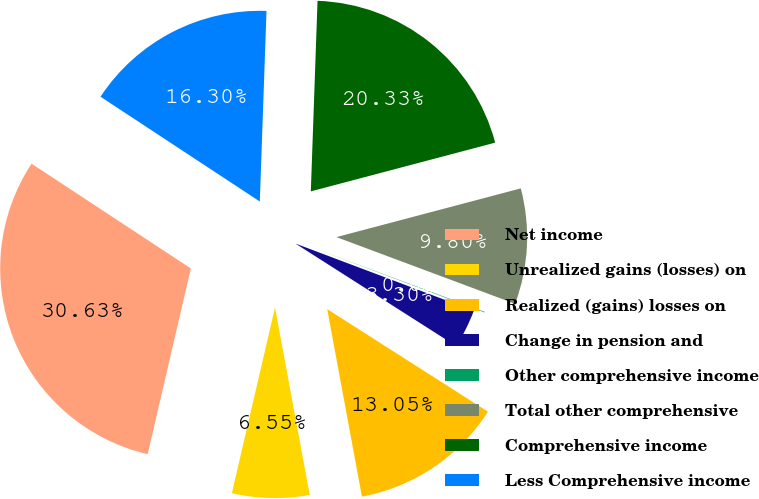Convert chart to OTSL. <chart><loc_0><loc_0><loc_500><loc_500><pie_chart><fcel>Net income<fcel>Unrealized gains (losses) on<fcel>Realized (gains) losses on<fcel>Change in pension and<fcel>Other comprehensive income<fcel>Total other comprehensive<fcel>Comprehensive income<fcel>Less Comprehensive income<nl><fcel>30.63%<fcel>6.55%<fcel>13.05%<fcel>3.3%<fcel>0.05%<fcel>9.8%<fcel>20.33%<fcel>16.3%<nl></chart> 